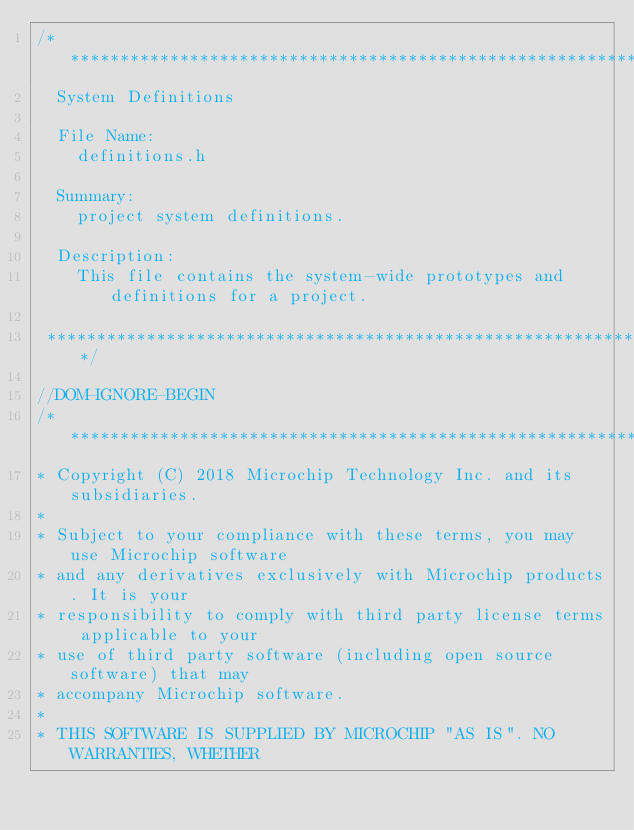<code> <loc_0><loc_0><loc_500><loc_500><_C_>/*******************************************************************************
  System Definitions

  File Name:
    definitions.h

  Summary:
    project system definitions.

  Description:
    This file contains the system-wide prototypes and definitions for a project.

 *******************************************************************************/

//DOM-IGNORE-BEGIN
/*******************************************************************************
* Copyright (C) 2018 Microchip Technology Inc. and its subsidiaries.
*
* Subject to your compliance with these terms, you may use Microchip software
* and any derivatives exclusively with Microchip products. It is your
* responsibility to comply with third party license terms applicable to your
* use of third party software (including open source software) that may
* accompany Microchip software.
*
* THIS SOFTWARE IS SUPPLIED BY MICROCHIP "AS IS". NO WARRANTIES, WHETHER</code> 